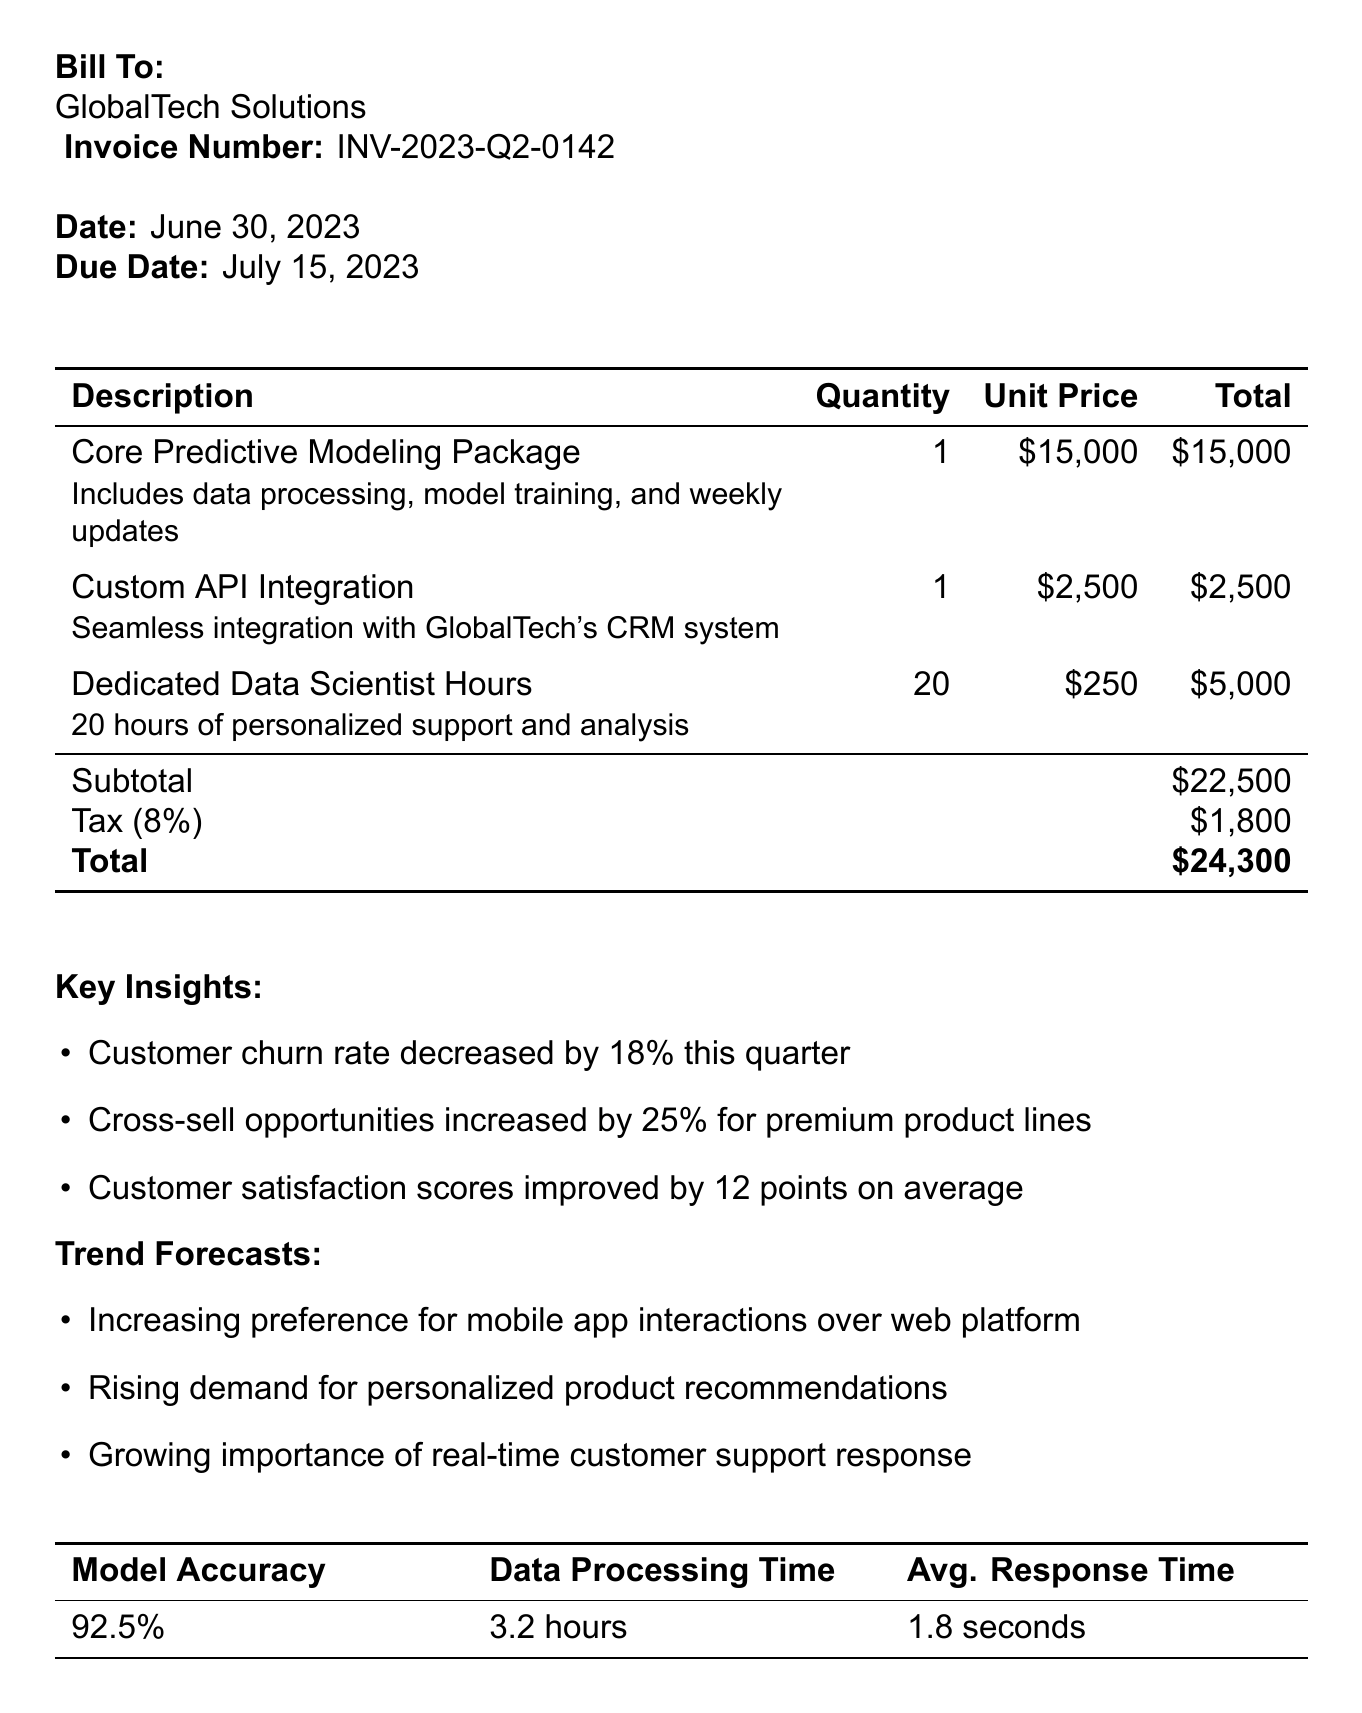What is the invoice number? The invoice number is explicitly stated in the document, which is used for reference and tracking.
Answer: INV-2023-Q2-0142 What is the total amount due? The total amount due is calculated from the subtotal plus tax; it is highlighted in the document.
Answer: $24,300 What is the tax rate applied? The tax rate is specified in the document and indicates the percentage of tax on the subtotal.
Answer: 8% Who is the account manager? The account manager's name is provided for client contact and assistance, which is important for client relations.
Answer: Sarah Thompson What was the customer churn rate decrease? The document contains insights regarding changes in customer behavior, including churn rate metrics.
Answer: 18% How many hours of support are included? The hours of personalized support are noted in one of the line items of the invoice.
Answer: 20 hours What should be discussed in the next steps? The next steps include planned actions for future engagement based on predictive modeling results.
Answer: AI-powered chatbot for customer service What is the payment term? Payment terms provide information regarding when the payment is due in relation to the invoice date.
Answer: Net 15 What is the forecasted trend regarding customer interactions? The document indicates future trends expected to impact business as identified in the analysis provided.
Answer: Mobile app interactions 